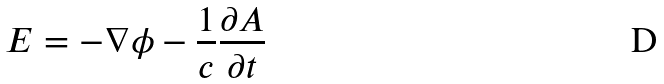Convert formula to latex. <formula><loc_0><loc_0><loc_500><loc_500>E = - \nabla \phi - \frac { 1 } { c } \frac { \partial A } { \partial t }</formula> 